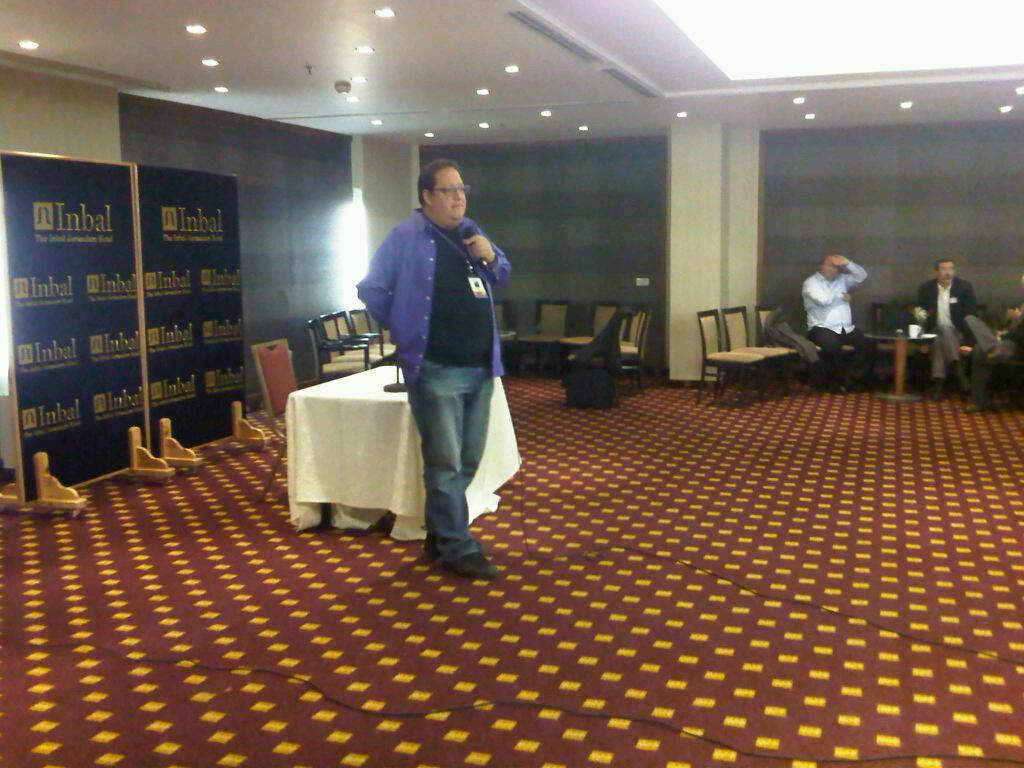What is the person in the image wearing? The person is wearing a violet shirt in the image. What is the person doing in the image? The person is standing and speaking in front of a microphone. How many people are sitting in the right corner of the image? There are three persons sitting in the right corner of the image. What type of cheese is being served to the potato in the image? There is no cheese or potato present in the image. 